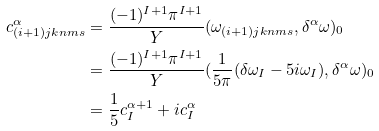<formula> <loc_0><loc_0><loc_500><loc_500>c ^ { \alpha } _ { ( i + 1 ) j k n m s } & = \frac { ( - 1 ) ^ { I + 1 } \pi ^ { I + 1 } } { Y } ( \omega _ { ( i + 1 ) j k n m s } , \delta ^ { \alpha } \omega ) _ { 0 } \\ & = \frac { ( - 1 ) ^ { I + 1 } \pi ^ { I + 1 } } { Y } ( \frac { 1 } { 5 \pi } ( \delta \omega _ { I } - 5 i \omega _ { I } ) , \delta ^ { \alpha } \omega ) _ { 0 } \\ & = \frac { 1 } { 5 } c ^ { \alpha + 1 } _ { I } + i c ^ { \alpha } _ { I }</formula> 